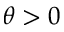<formula> <loc_0><loc_0><loc_500><loc_500>\theta > 0</formula> 